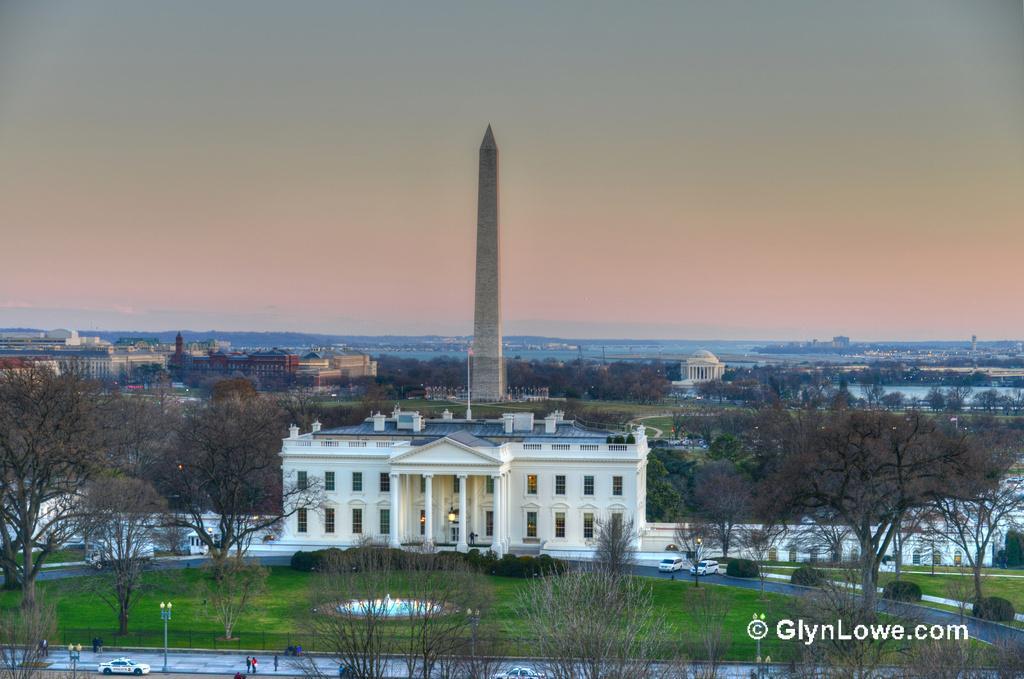In one or two sentences, can you explain what this image depicts? In this image, there are a few buildings. We can see some trees and plants. We can see some grass and the fountain. There are a few people and vehicles. We can see some water and the sky. We can see some poles. We can see the ground. 